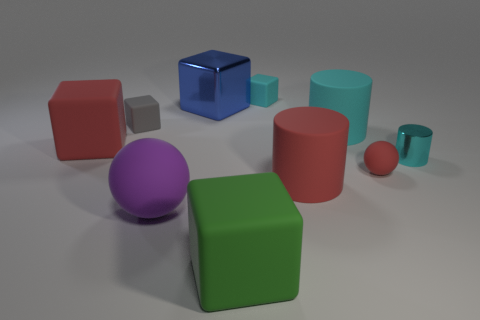Subtract 2 blocks. How many blocks are left? 3 Subtract all brown cubes. Subtract all red spheres. How many cubes are left? 5 Subtract all spheres. How many objects are left? 8 Add 8 large metallic blocks. How many large metallic blocks are left? 9 Add 5 large blue metallic blocks. How many large blue metallic blocks exist? 6 Subtract 1 purple spheres. How many objects are left? 9 Subtract all tiny metal objects. Subtract all big cyan things. How many objects are left? 8 